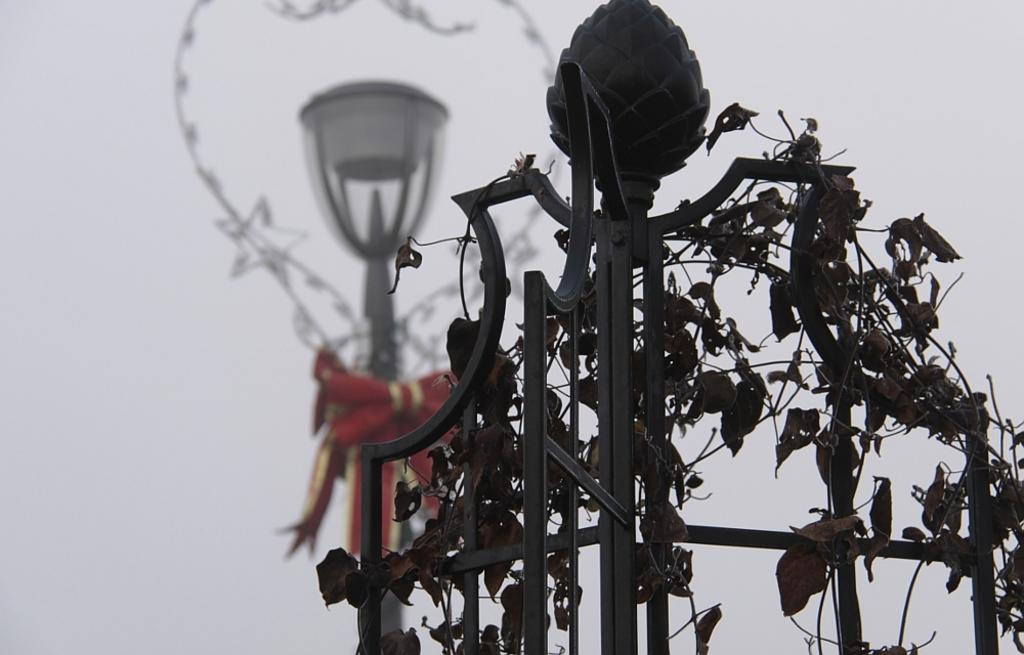What type of vegetation can be seen in the image? There are dry leaves in the image that resemble creepers. How are the creepers supported in the image? The creepers are on metal rods. What can be seen in the background of the image? There is a street light in the background of the image. Are there any additional decorative elements associated with the street light? Yes, there are decorative items associated with the street light. What type of health benefits can be gained from the yam in the image? There is no yam present in the image; it features dry leaves resembling creepers on metal rods and a street light in the background. How does the breath of the person in the image affect the creepers? There is no person present in the image, so their breath cannot affect the creepers. 